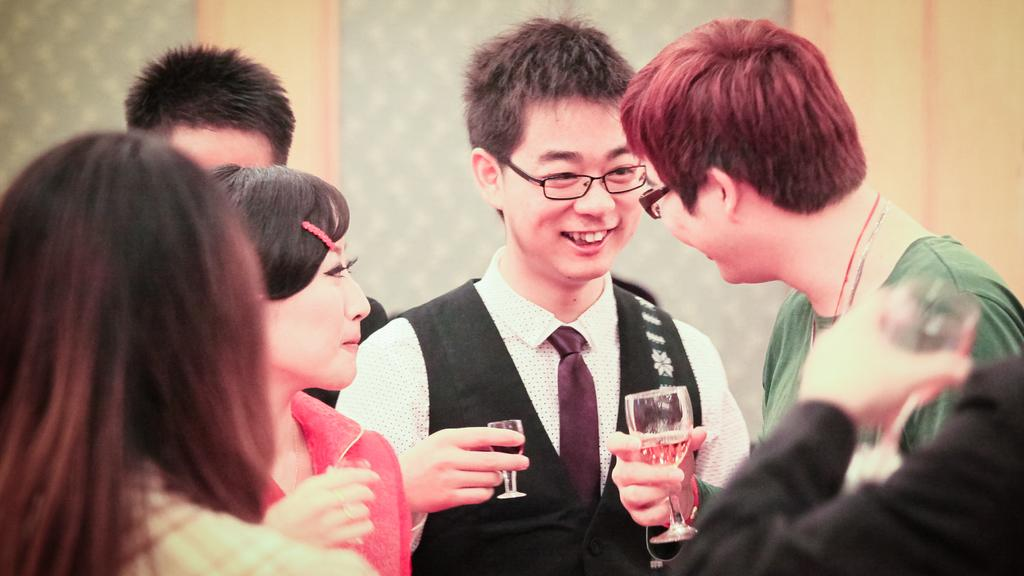How many people are present in the image? There are six people in the image. What are some of the people holding in the image? Four of the people are holding drink glasses. What can be seen in the background of the image? There is a big wall in the background of the image. What color is the worm crawling on the wall in the image? There is no worm present in the image, so it is not possible to determine its color. 